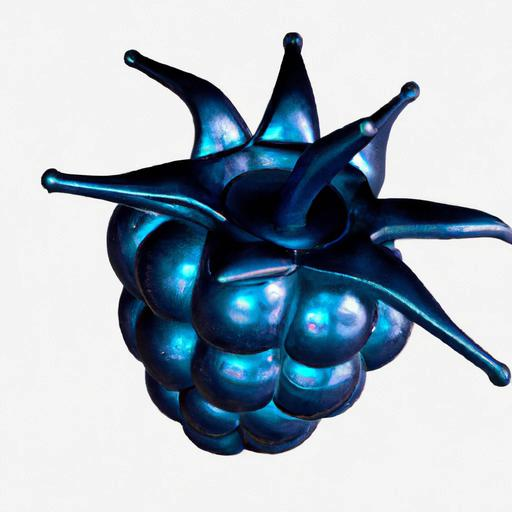Is the composition centered? Yes, the composition is centered with the subject—a stylized, possibly metallic or ceramic, blue object shaped like a berry or bunch of grapes—positioned in the middle of the frame, drawing the viewer's attention directly to it. 